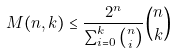<formula> <loc_0><loc_0><loc_500><loc_500>M ( n , k ) \leq \frac { 2 ^ { n } } { \sum _ { i = 0 } ^ { k } { n \choose i } } { n \choose k }</formula> 